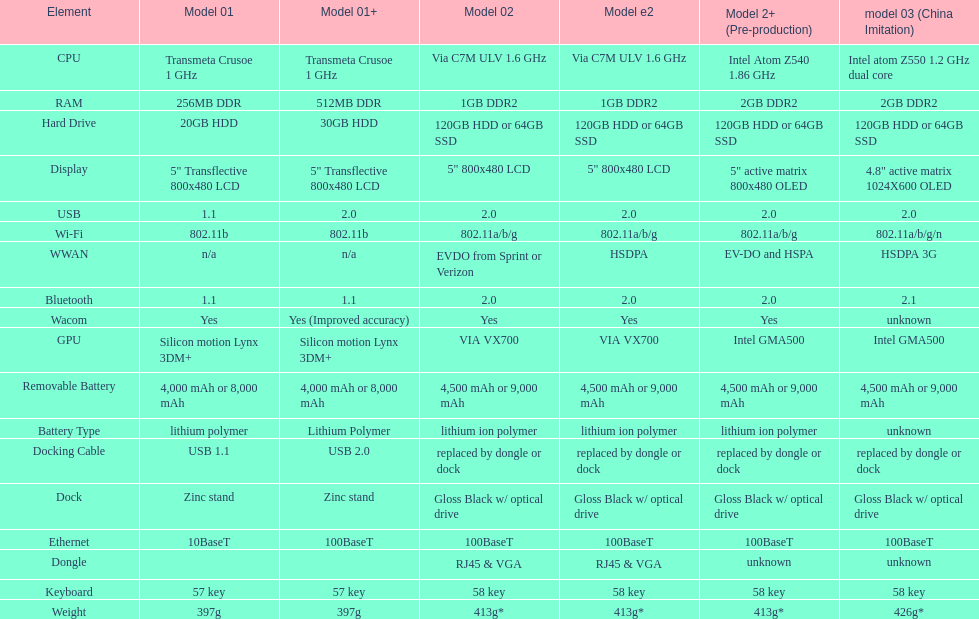What is the component before usb? Display. 